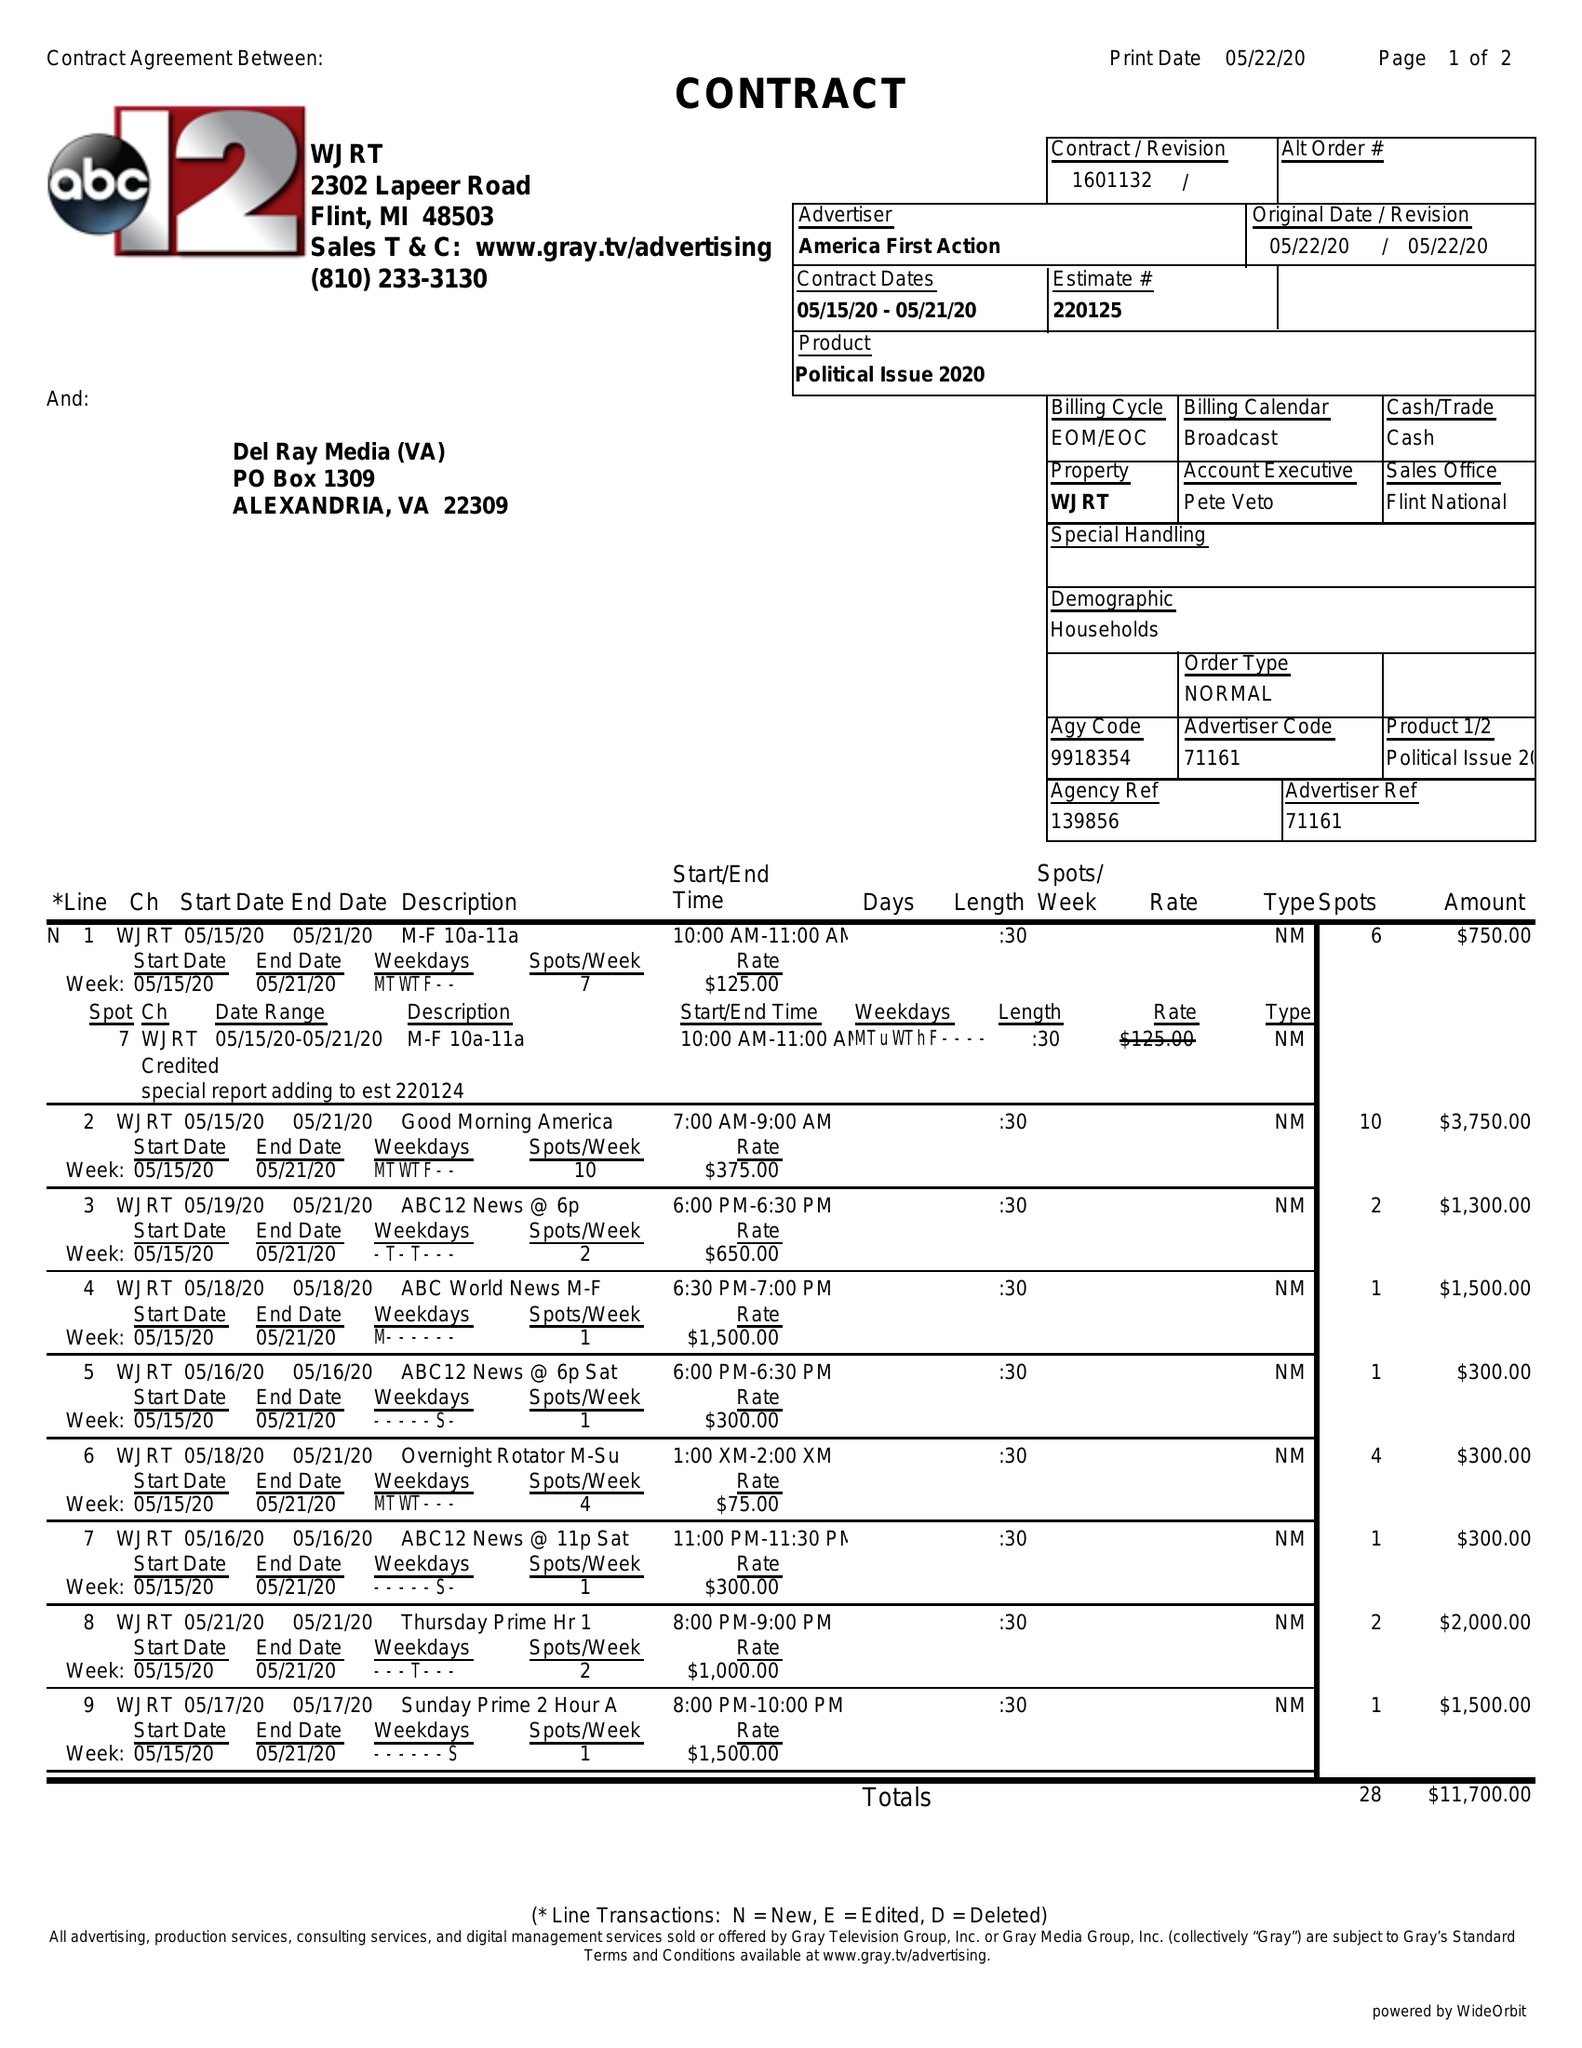What is the value for the contract_num?
Answer the question using a single word or phrase. 1601132 